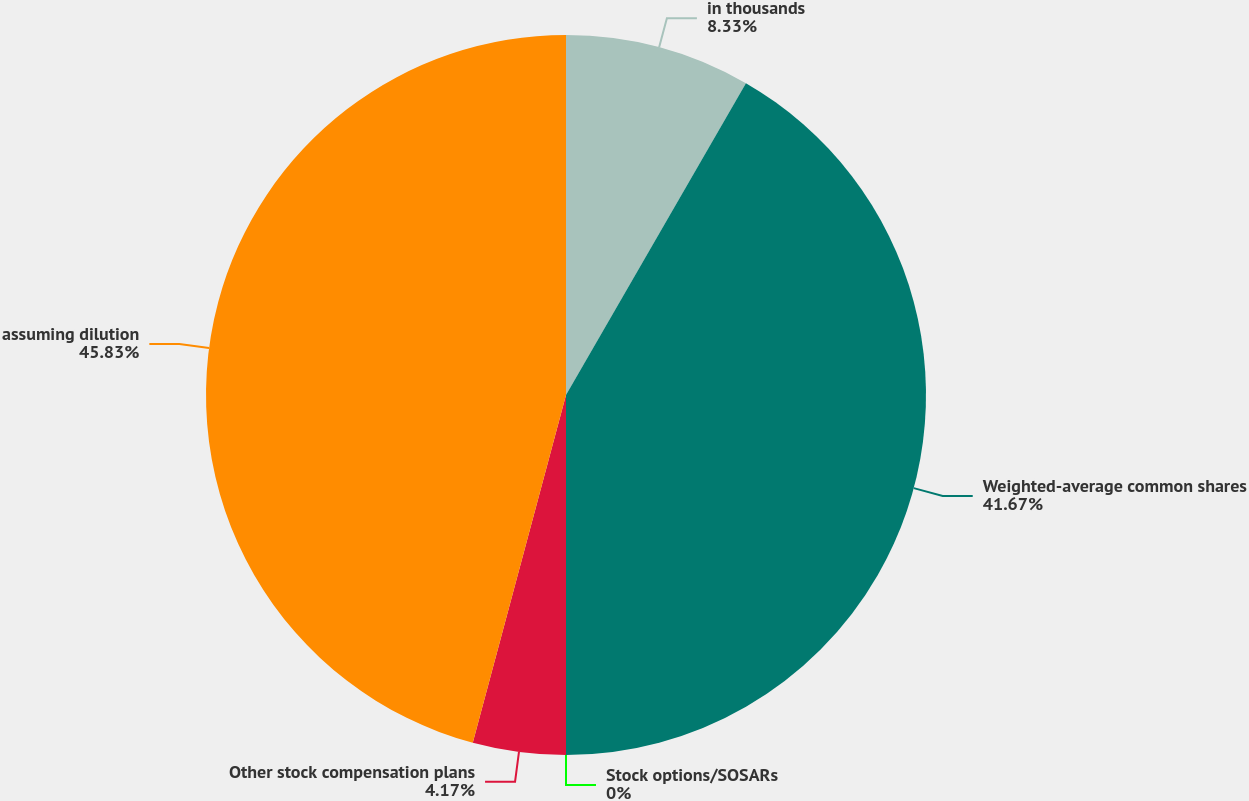<chart> <loc_0><loc_0><loc_500><loc_500><pie_chart><fcel>in thousands<fcel>Weighted-average common shares<fcel>Stock options/SOSARs<fcel>Other stock compensation plans<fcel>assuming dilution<nl><fcel>8.33%<fcel>41.67%<fcel>0.0%<fcel>4.17%<fcel>45.83%<nl></chart> 